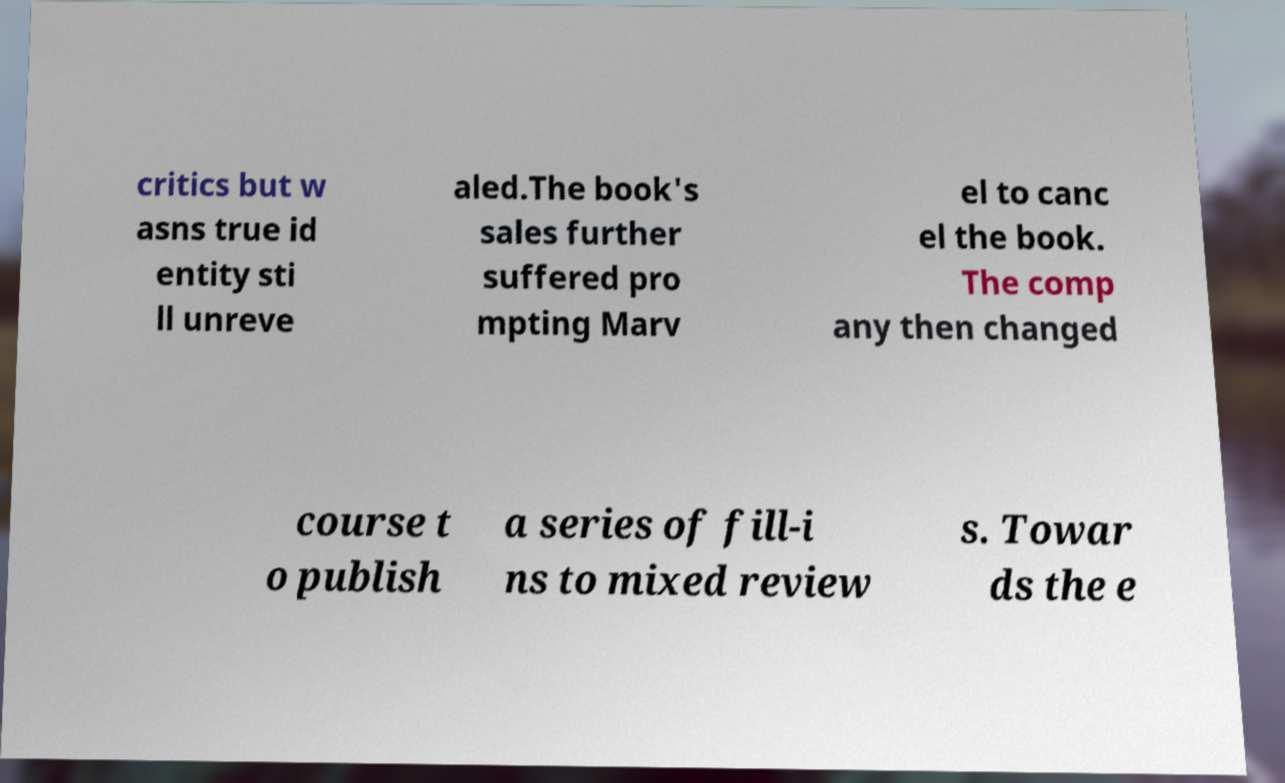What messages or text are displayed in this image? I need them in a readable, typed format. critics but w asns true id entity sti ll unreve aled.The book's sales further suffered pro mpting Marv el to canc el the book. The comp any then changed course t o publish a series of fill-i ns to mixed review s. Towar ds the e 